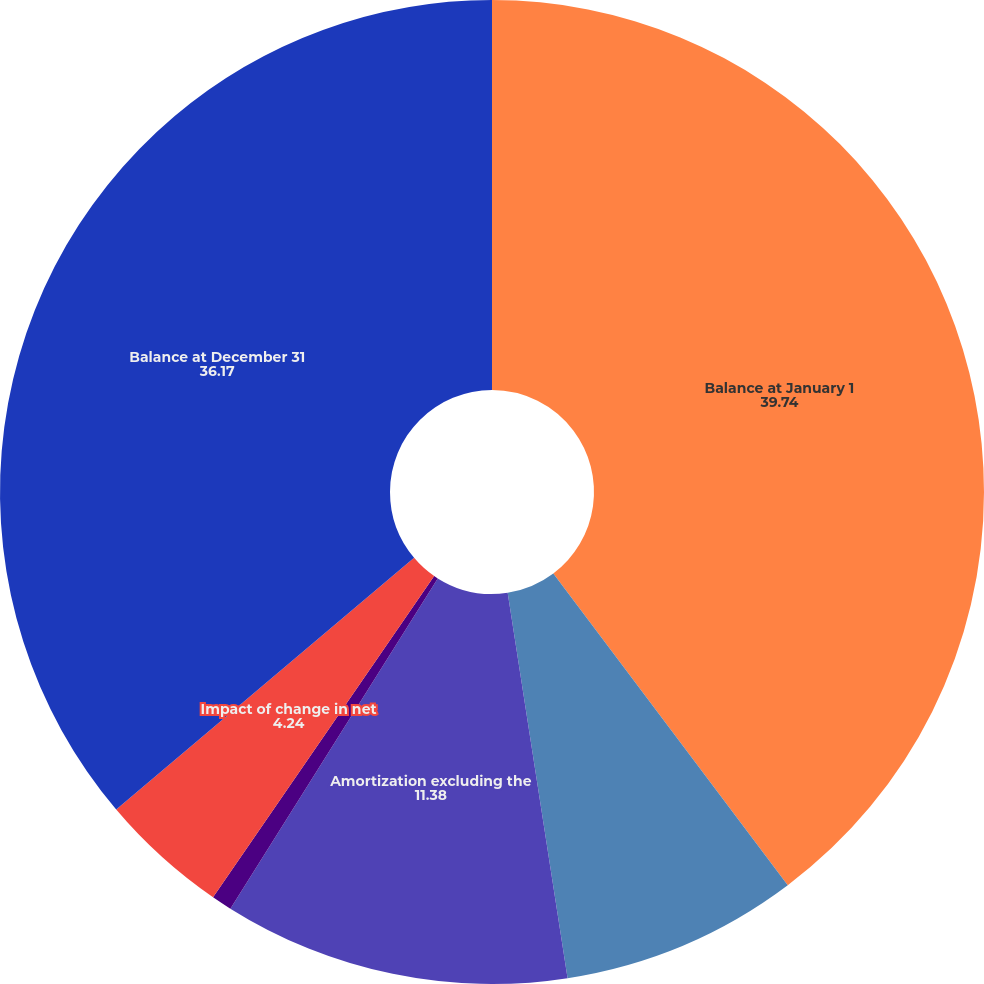Convert chart. <chart><loc_0><loc_0><loc_500><loc_500><pie_chart><fcel>Balance at January 1<fcel>Capitalization of acquisition<fcel>Amortization excluding the<fcel>Amortization impact of<fcel>Impact of change in net<fcel>Balance at December 31<nl><fcel>39.74%<fcel>7.81%<fcel>11.38%<fcel>0.67%<fcel>4.24%<fcel>36.17%<nl></chart> 